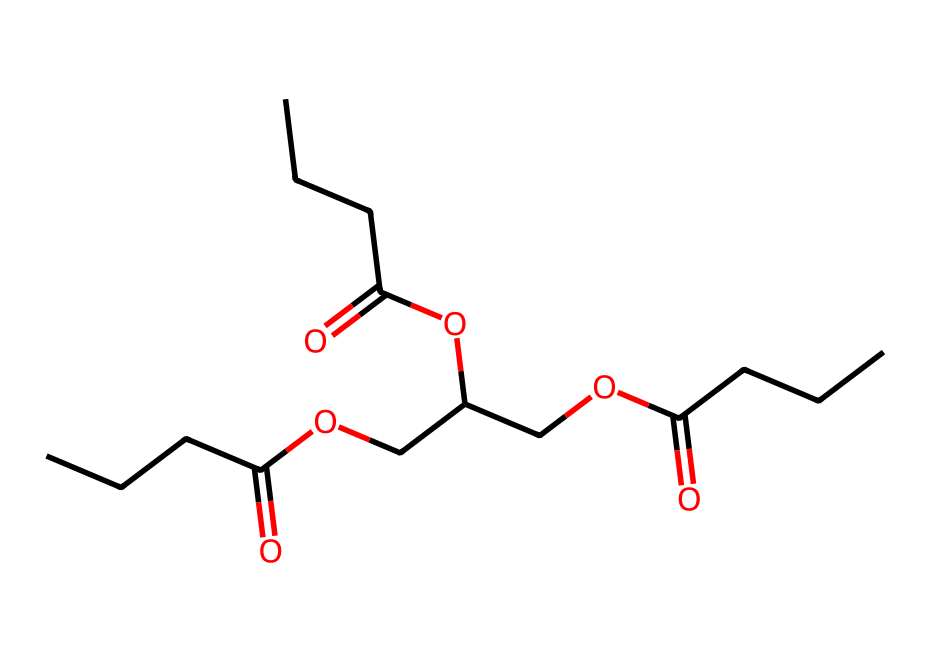What is the main functional group present in this chemical? The chemical structure shows a carboxylic acid group (-COOH) due to the presence of the double bond to an oxygen followed by an -O- connected to another carbon chain. This functional group is essential for its solubility in water and its biodegradable nature.
Answer: carboxylic acid How many carbon atoms are in the structure? By analyzing the SMILES representation, I count a total of 15 carbon atoms present in all the segments of the chemical. Each carbon in the chain is accounted for to find the total number.
Answer: 15 What type of chemical classification does this compound belong to? The presence of multiple -COOH groups and ether linkages indicates that this compound is classified as an ester, often associated with biodegradable solvents and thinners, which are less harmful to the environment.
Answer: ester What is the molecular formula derived from the SMILES? By interpreting the SMILES notation, the molecule can be broken down to find the ratios of carbon, hydrogen, and oxygen, leading to the complete molecular formula of C15H28O5. This is determined by counting the number of each type of atom represented.
Answer: C15H28O5 How many ester linkages are present in this molecule? Examining the structure represents two ester linkages, which are indicated by the -OC(=O)- connections that involve carbon chains linked via oxygen atoms to carbonyl groups. Counting these connections gives two distinct ester functionalities.
Answer: 2 